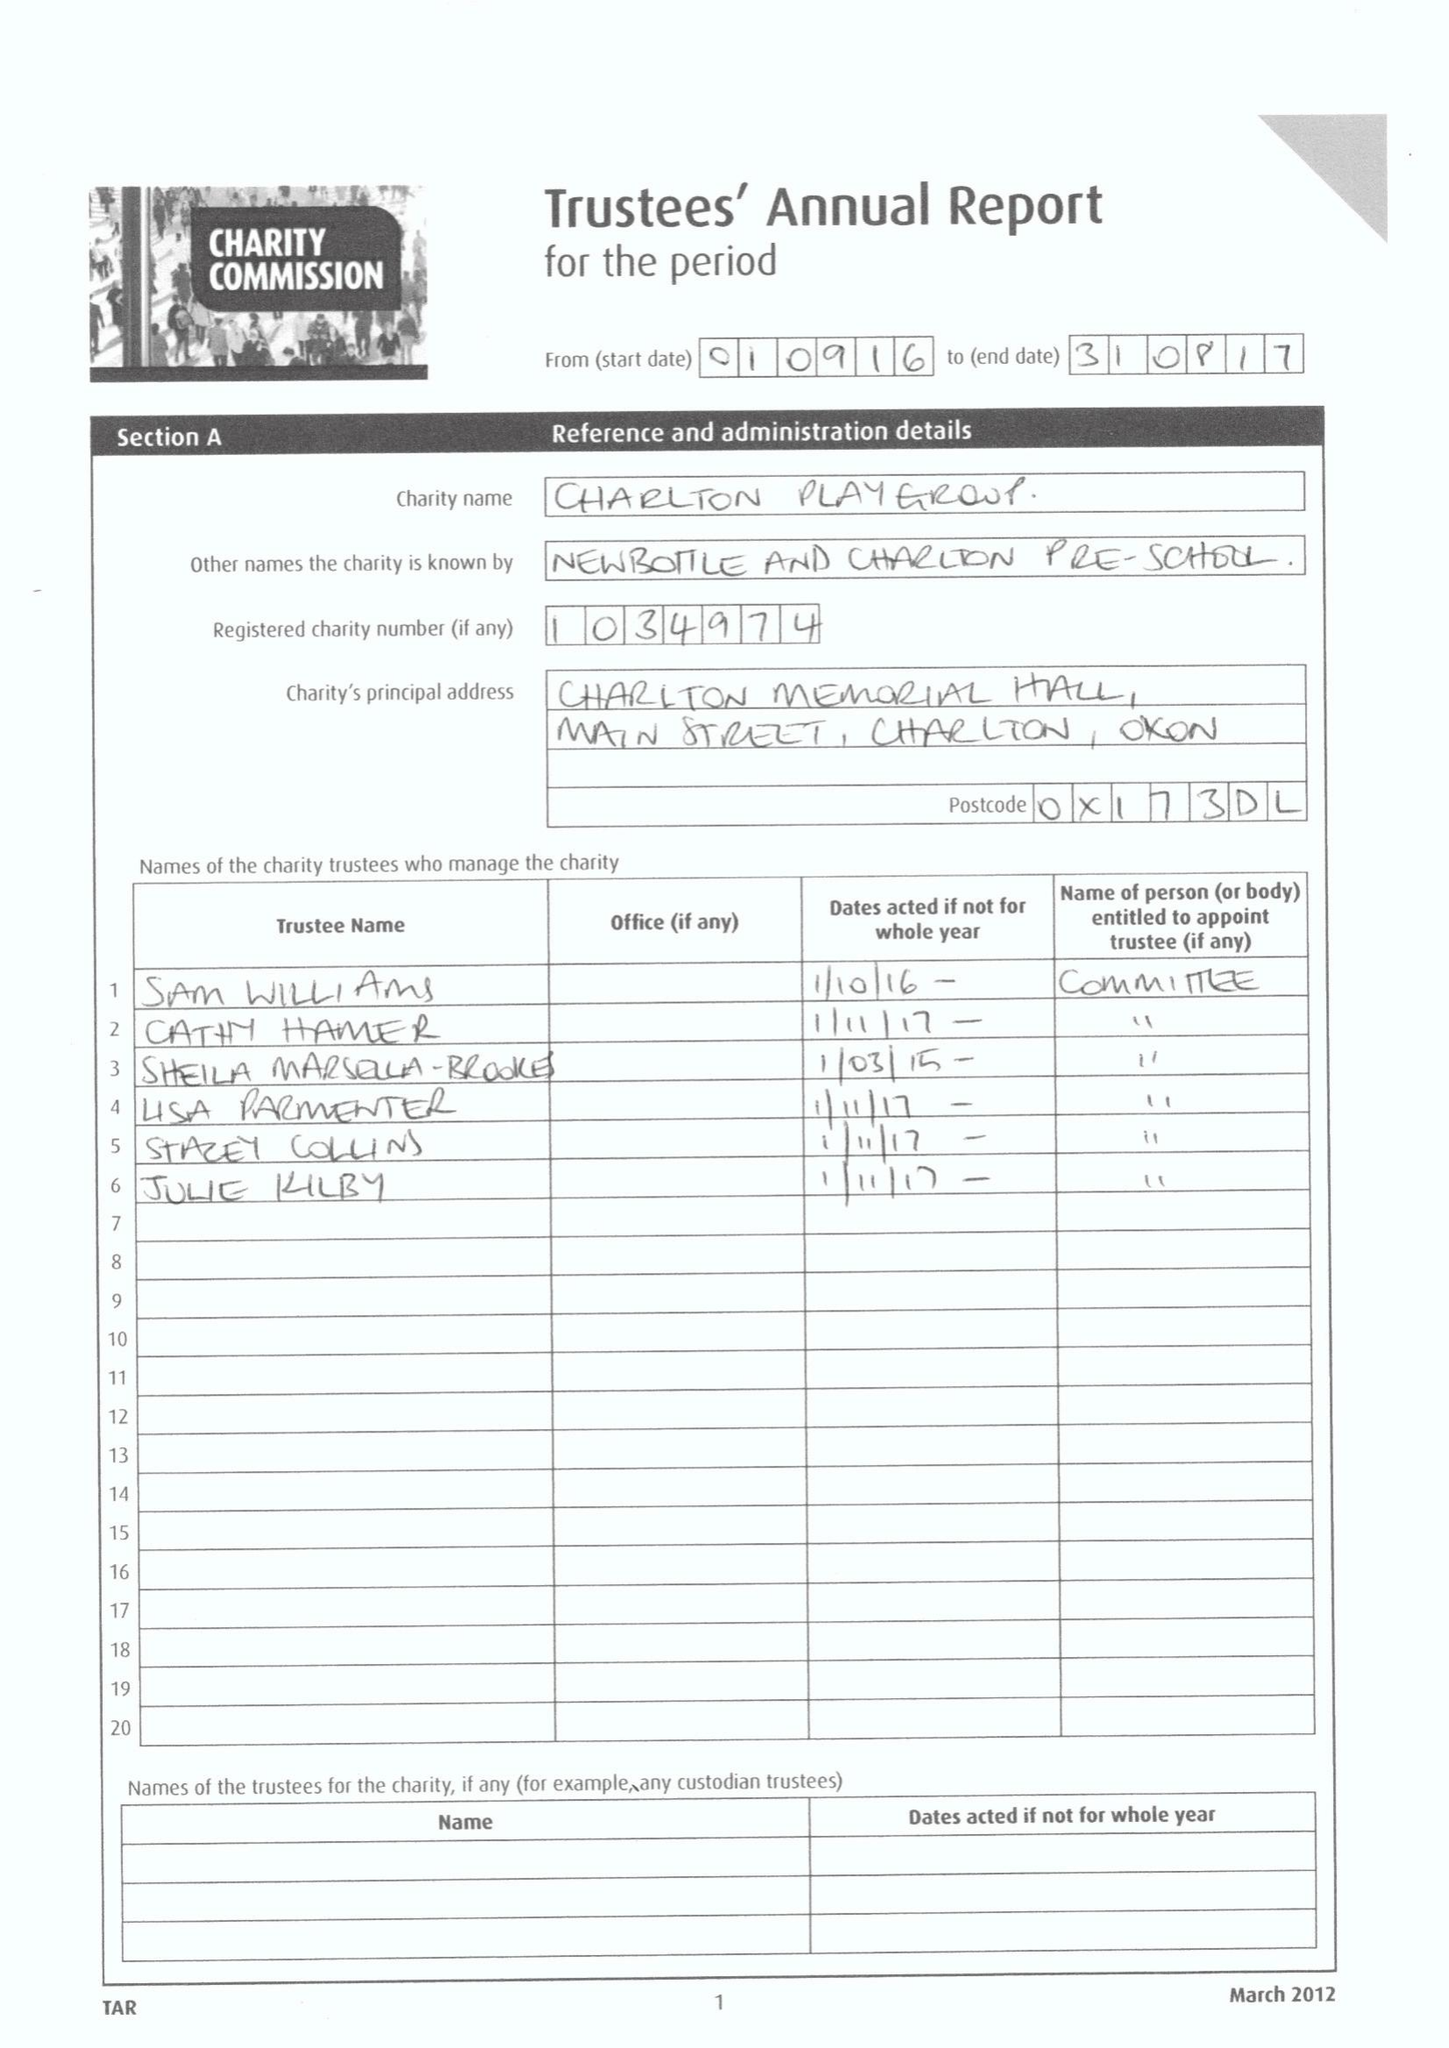What is the value for the address__street_line?
Answer the question using a single word or phrase. MAIN STREET 